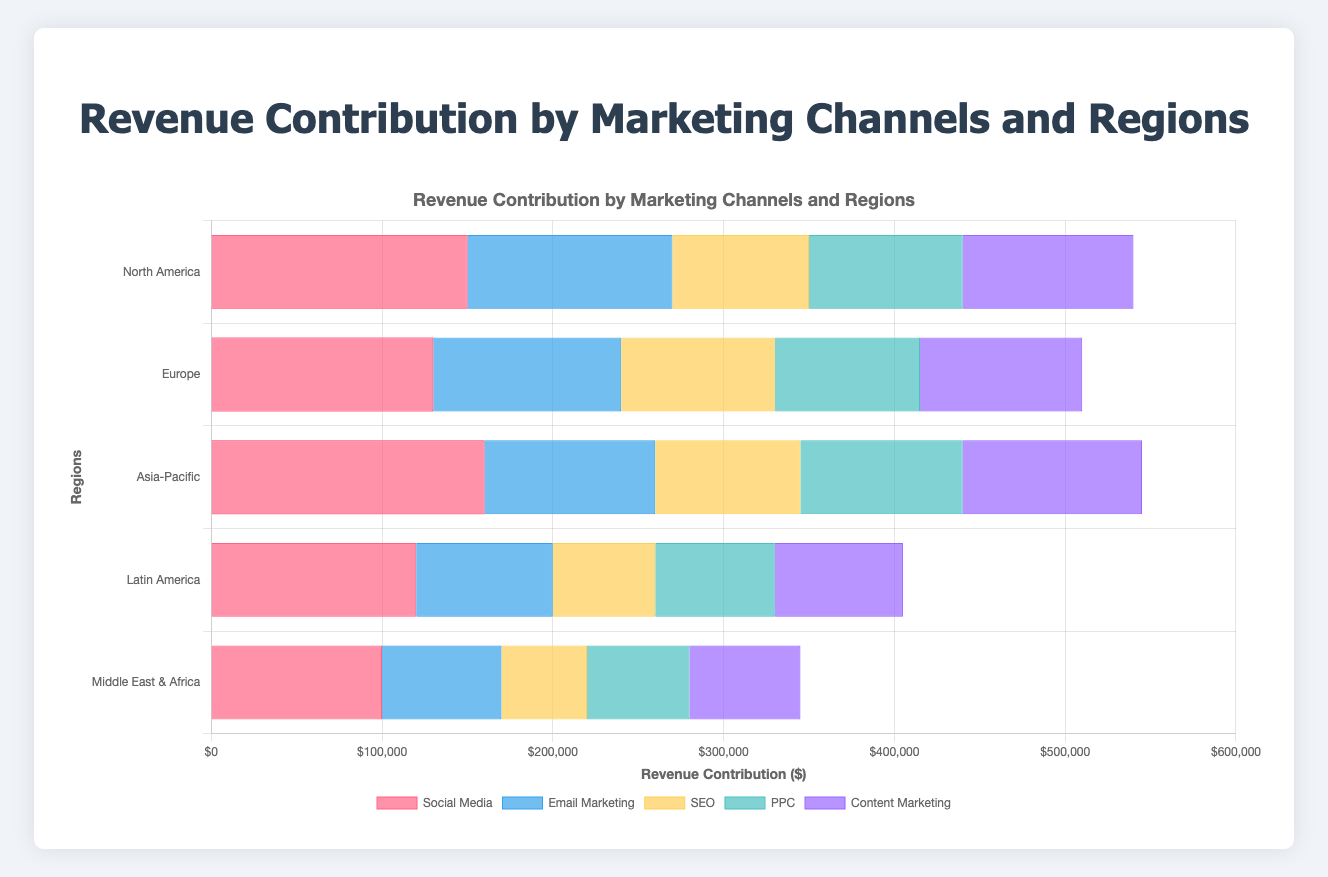Which region has the highest revenue contribution from Social Media? By looking at the bar lengths for Social Media, we can compare the values. Asia-Pacific has the longest bar, indicating the highest revenue contribution.
Answer: Asia-Pacific What is the total revenue contribution from Email Marketing across all regions? Summing up the revenue contributions from Email Marketing in all regions: 120000 (North America) + 110000 (Europe) + 100000 (Asia-Pacific) + 80000 (Latin America) + 70000 (Middle East & Africa) = 480000
Answer: 480000 Which marketing channel has the least revenue contribution in Europe? Looking at the bars for Europe, the shortest bar belongs to PPC.
Answer: PPC Compare the total revenue contribution from PPC in North America and Europe. Which one is greater? North America has a PPC contribution of 90000, and Europe has 85000. Comparing these values, North America's contribution is greater.
Answer: North America What is the difference in revenue contribution from Content Marketing between Asia-Pacific and Latin America? Subtract the revenue contribution from Content Marketing in Latin America (75000) from Asia-Pacific (105000): 105000 - 75000 = 30000
Answer: 30000 Which marketing channel has the highest combined revenue contribution across all regions? To find the highest combined contribution, we sum the revenue from each channel across all regions and compare:
- Social Media: 150000 + 130000 + 160000 + 120000 + 100000 = 660000
- Email Marketing: 120000 + 110000 + 100000 + 80000 + 70000 = 480000
- SEO: 80000 + 90000 + 85000 + 60000 + 50000 = 365000
- PPC: 90000 + 85000 + 95000 + 70000 + 60000 = 400000
- Content Marketing: 100000 + 95000 + 105000 + 75000 + 65000 = 440000
The highest value is for Social Media.
Answer: Social Media In which region does SEO contribute the least to total revenue? By comparing the lengths of the SEO bars in each region, the shortest bar is found in the Middle East & Africa.
Answer: Middle East & Africa What is the average revenue contribution from PPC across all regions? Summing up the PPC revenue contributions and dividing by the number of regions: (90000 + 85000 + 95000 + 70000 + 60000) / 5 = 80000
Answer: 80000 Which region has a higher total revenue contribution from marketing channels, North America or Asia-Pacific? Summing the contributions for North America: 150000 (Social Media) + 120000 (Email Marketing) + 80000 (SEO) + 90000 (PPC) + 100000 (Content Marketing) = 540000. Summing the contributions for Asia-Pacific: 160000 (Social Media) + 100000 (Email Marketing) + 85000 (SEO) + 95000 (PPC) + 105000 (Content Marketing) = 545000. Asia-Pacific has a higher total revenue.
Answer: Asia-Pacific How does the revenue contribution of Social Media in Latin America compare to that of the Middle East & Africa? The contribution from Social Media in Latin America is 120000, while in the Middle East & Africa, it is 100000. Therefore, Latin America has a higher contribution.
Answer: Latin America 